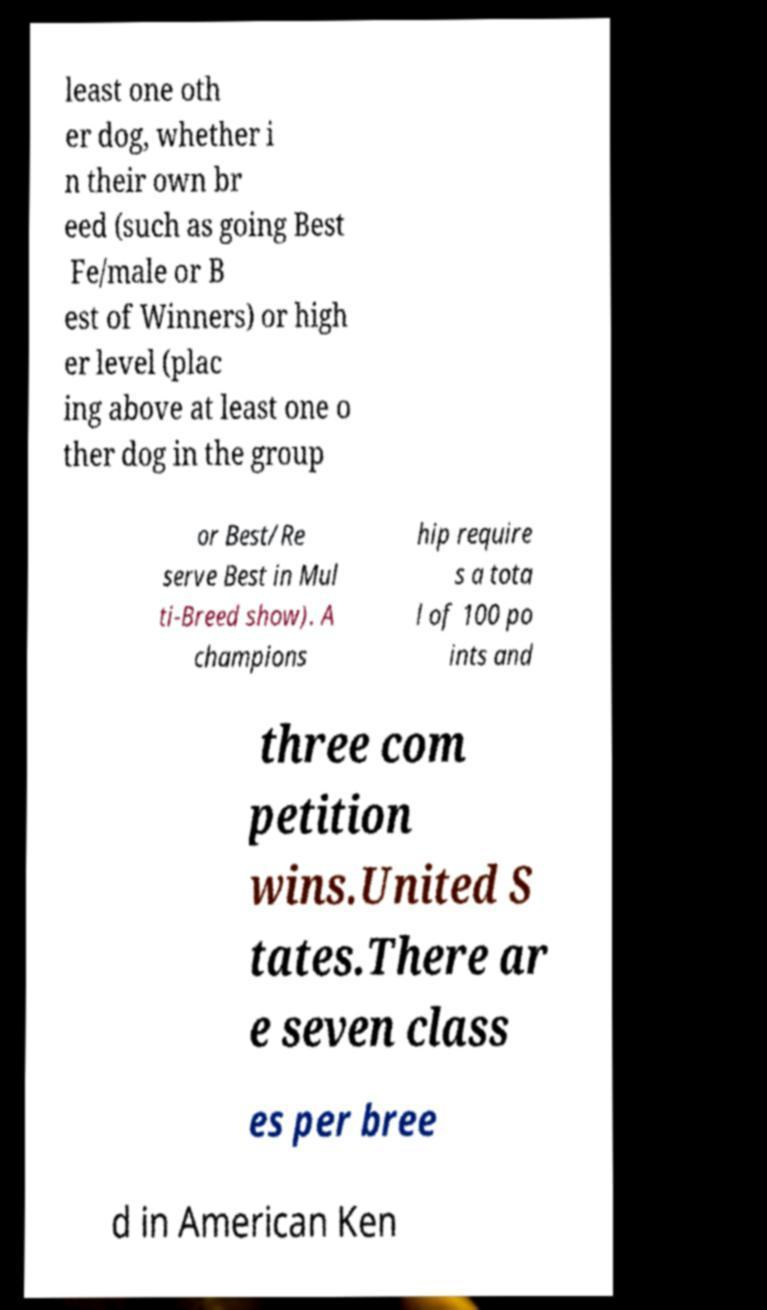Please read and relay the text visible in this image. What does it say? least one oth er dog, whether i n their own br eed (such as going Best Fe/male or B est of Winners) or high er level (plac ing above at least one o ther dog in the group or Best/Re serve Best in Mul ti-Breed show). A champions hip require s a tota l of 100 po ints and three com petition wins.United S tates.There ar e seven class es per bree d in American Ken 